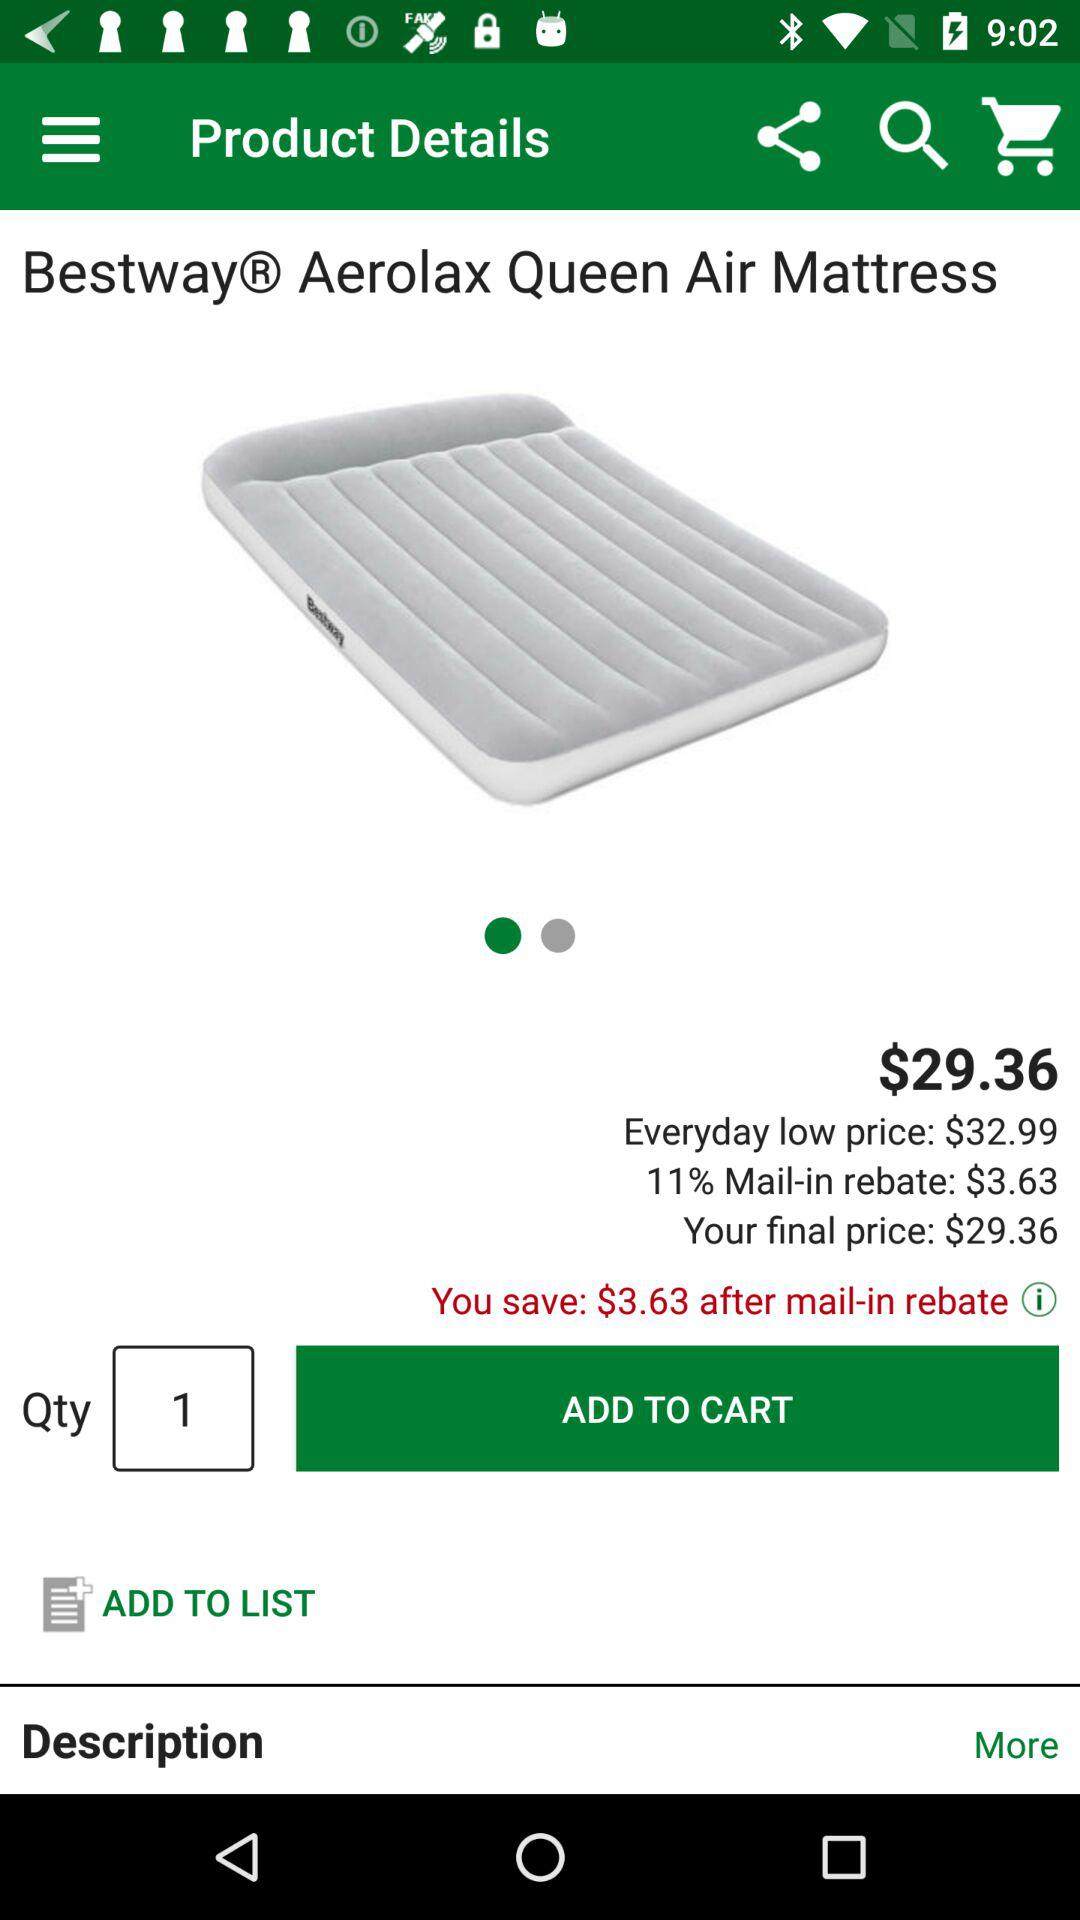How much money can I save after the mail-in rebate? You can save $3.63 after the mail-in rebate. 